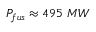<formula> <loc_0><loc_0><loc_500><loc_500>P _ { f u s } \approx 4 9 5 M W</formula> 